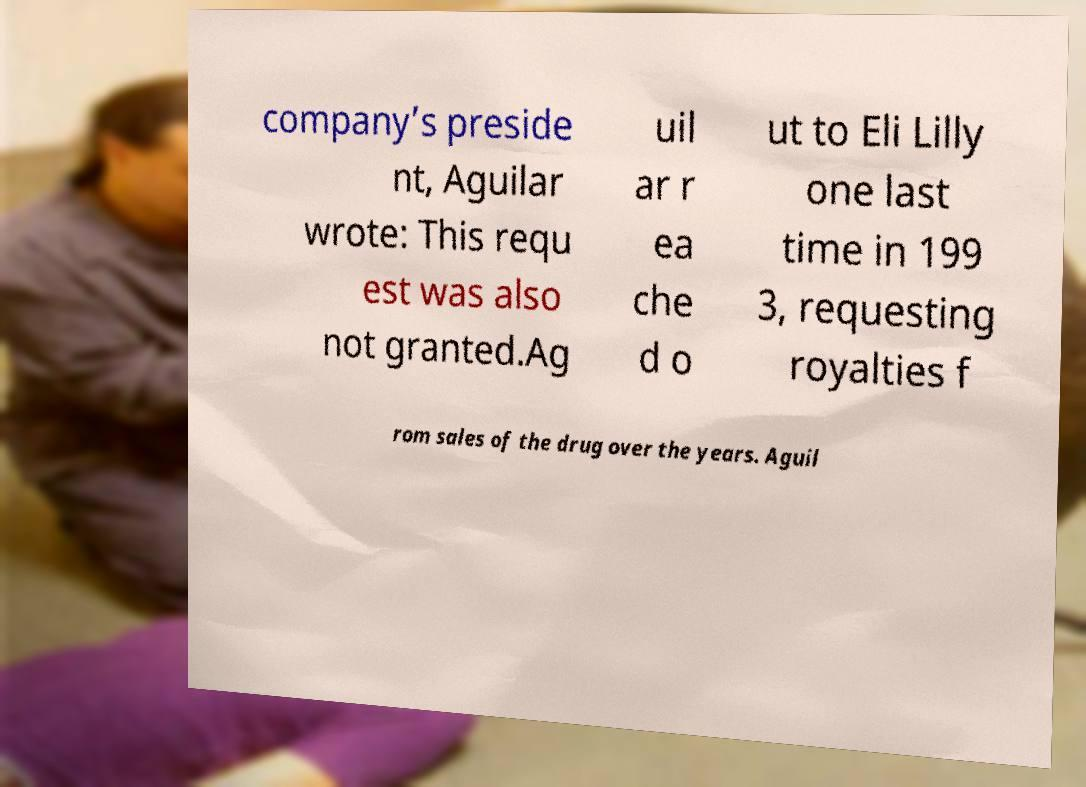There's text embedded in this image that I need extracted. Can you transcribe it verbatim? company’s preside nt, Aguilar wrote: This requ est was also not granted.Ag uil ar r ea che d o ut to Eli Lilly one last time in 199 3, requesting royalties f rom sales of the drug over the years. Aguil 